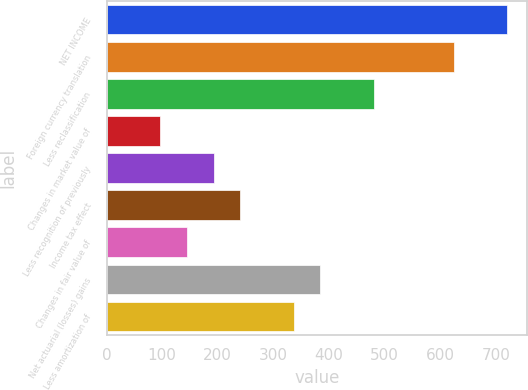Convert chart. <chart><loc_0><loc_0><loc_500><loc_500><bar_chart><fcel>NET INCOME<fcel>Foreign currency translation<fcel>Less reclassification<fcel>Changes in market value of<fcel>Less recognition of previously<fcel>Income tax effect<fcel>Changes in fair value of<fcel>Net actuarial (losses) gains<fcel>Less amortization of<nl><fcel>720.65<fcel>624.59<fcel>480.5<fcel>96.26<fcel>192.32<fcel>240.35<fcel>144.29<fcel>384.44<fcel>336.41<nl></chart> 